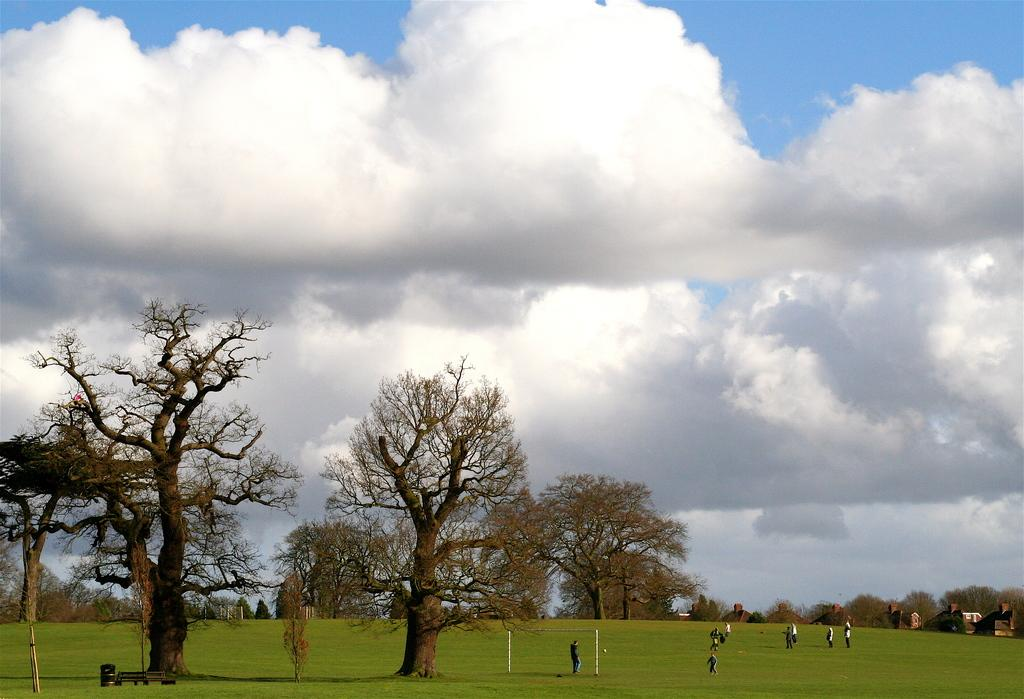What type of landscape is depicted in the image? The image features grassland and trees. Where are the grassland and trees located in the image? The grassland and trees are at the bottom side of the image. What else can be seen in the image besides the grassland and trees? The sky is visible in the image. Where is the sky located in the image? The sky is at the top side of the image. What type of waste is being disposed of in the grassland in the image? There is no waste being disposed of in the grassland in the image. What story is being told by the trees in the image? The trees in the image are not telling a story; they are simply depicted as part of the landscape. 